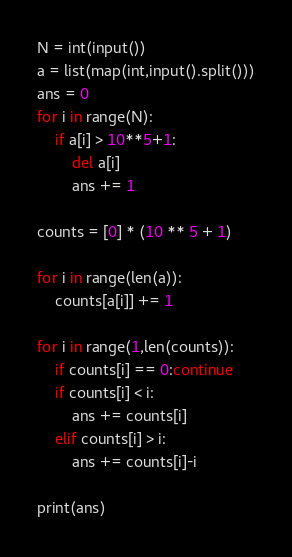<code> <loc_0><loc_0><loc_500><loc_500><_Python_>N = int(input())
a = list(map(int,input().split()))
ans = 0
for i in range(N):
    if a[i] > 10**5+1:
        del a[i]
        ans += 1
        
counts = [0] * (10 ** 5 + 1)

for i in range(len(a)):
    counts[a[i]] += 1
    
for i in range(1,len(counts)):
    if counts[i] == 0:continue
    if counts[i] < i:
        ans += counts[i]
    elif counts[i] > i:
        ans += counts[i]-i
        
print(ans)</code> 